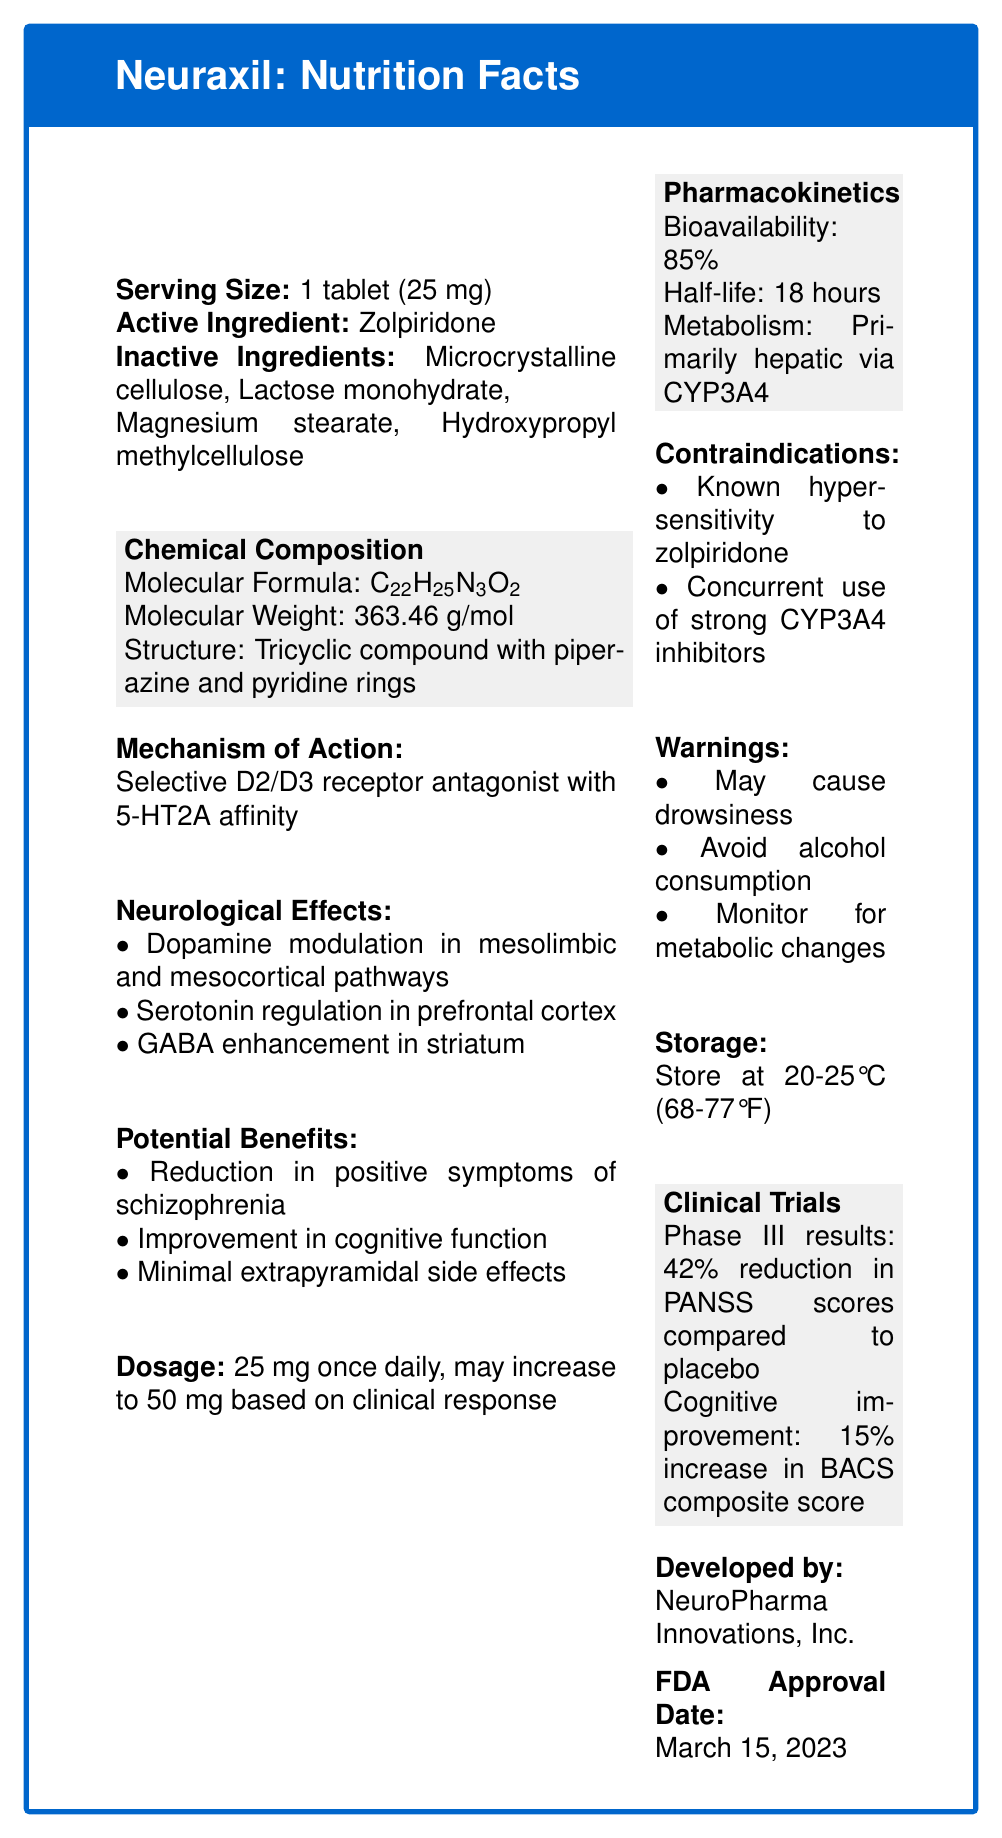What is the active ingredient in Neuraxil? The document specifies that the active ingredient in Neuraxil is Zolpiridone.
Answer: Zolpiridone What is the serving size for Neuraxil? The serving size is listed as 1 tablet (25 mg) in the document.
Answer: 1 tablet (25 mg) What is the storage temperature for Neuraxil? The document advises storing Neuraxil at 20-25°C (68-77°F).
Answer: 20-25°C (68-77°F) Is Zolpiridone a selective D2/D3 receptor antagonist? The document states that Zolpiridone is a selective D2/D3 receptor antagonist with 5-HT2A affinity.
Answer: Yes What is the half-life of Neuraxil? The half-life is listed as 18 hours in the pharmacokinetics section of the document.
Answer: 18 hours Which of the following is NOT an inactive ingredient in Neuraxil?
A. Microcrystalline cellulose
B. Lactose monohydrate
C. Aspirin 
D. Magnesium stearate The document lists Microcrystalline cellulose, Lactose monohydrate, and Magnesium stearate as inactive ingredients. Aspirin is not listed.
Answer: C. Aspirin How many types of neurological effects are mentioned for Neuraxil?
I. Dopamine modulation in mesolimbic and mesocortical pathways
II. Serotonin regulation in prefrontal cortex
III. GABA enhancement in striatum
IV. Calcium channel blockade
A. I and II 
B. I, II, and III 
C. I, II, III, and IV 
D. I and IV The document lists three neurological effects: Dopamine modulation in mesolimbic and mesocortical pathways, Serotonin regulation in prefrontal cortex, and GABA enhancement in striatum.
Answer: B. I, II, and III Should alcohol consumption be avoided while taking Neuraxil? The document warns against alcohol consumption while taking Neuraxil.
Answer: Yes Summarize the key points of Neuraxil as presented in the document. The document covers all the mentioned aspects in Neuraxil's composition, usage, benefits, pharmacokinetics, and warnings.
Answer: Neuraxil is an antipsychotic medication containing Zolpiridone. It acts as a selective D2/D3 receptor antagonist with affinity for 5-HT2A. The drug modulates dopamine, serotonin, and GABA pathways, offering benefits such as reduced schizophrenia symptoms and cognitive improvement with minimal side effects. The recommended dosage starts at 25 mg, adjustable to 50 mg. It has high bioavailability and an 18-hour half-life, metabolized primarily via CYP3A4. Storage at 20-25°C is advised, and it carries warnings regarding drowsiness and the need to avoid alcohol. What increase in the BACS composite score was observed in clinical trials for Neuraxil? The document reports a 15% increase in the BACS composite score for cognitive improvement in clinical trials.
Answer: 15% What is the molecular weight of Zolpiridone? The molecular weight of Zolpiridone is listed as 363.46 g/mol in the document.
Answer: 363.46 g/mol Who developed Neuraxil? The document states that Neuraxil was developed by NeuroPharma Innovations, Inc.
Answer: NeuroPharma Innovations, Inc. Can Neuraxil be prescribed to patients with known hypersensitivity to zolpiridone? The document lists known hypersensitivity to zolpiridone as a contraindication for prescribing Neuraxil.
Answer: No What is the bioavailability of Neuraxil? The pharmacokinetics section of the document states that the bioavailability of Neuraxil is 85%.
Answer: 85% Which enzyme primarily metabolizes Neuraxil? The document shows that the metabolism of Neuraxil is primarily hepatic via CYP3A4.
Answer: CYP3A4 Does Neuraxil have a high or low potential for causing extrapyramidal side effects? The document mentions that Neuraxil has minimal extrapyramidal side effects.
Answer: Low potential What are the exact chemical structure components mentioned in the document for Zolpiridone? The document describes the chemical structure as a tricyclic compound with piperazine and pyridine rings.
Answer: Tricyclic compound with piperazine and pyridine rings Which condition was not specifically detailed in the clinical trials results in the document? The clinical trial results for Neuraxil detailed reductions in PANSS scores and cognitive improvement but did not specify effects on depressive symptoms.
Answer: The reduction in depressive symptoms 